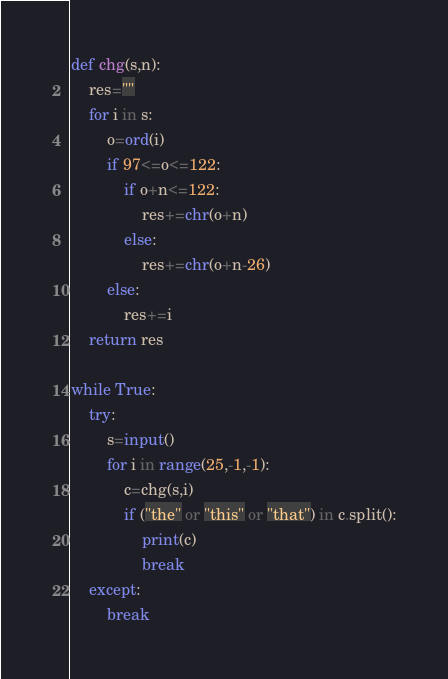<code> <loc_0><loc_0><loc_500><loc_500><_Python_>def chg(s,n):
    res=""
    for i in s:
        o=ord(i)
        if 97<=o<=122:
            if o+n<=122:
                res+=chr(o+n)
            else:
                res+=chr(o+n-26)
        else:
            res+=i
    return res

while True:
    try:
        s=input()
        for i in range(25,-1,-1):
            c=chg(s,i)
            if ("the" or "this" or "that") in c.split():
                print(c)
                break
    except:
        break</code> 